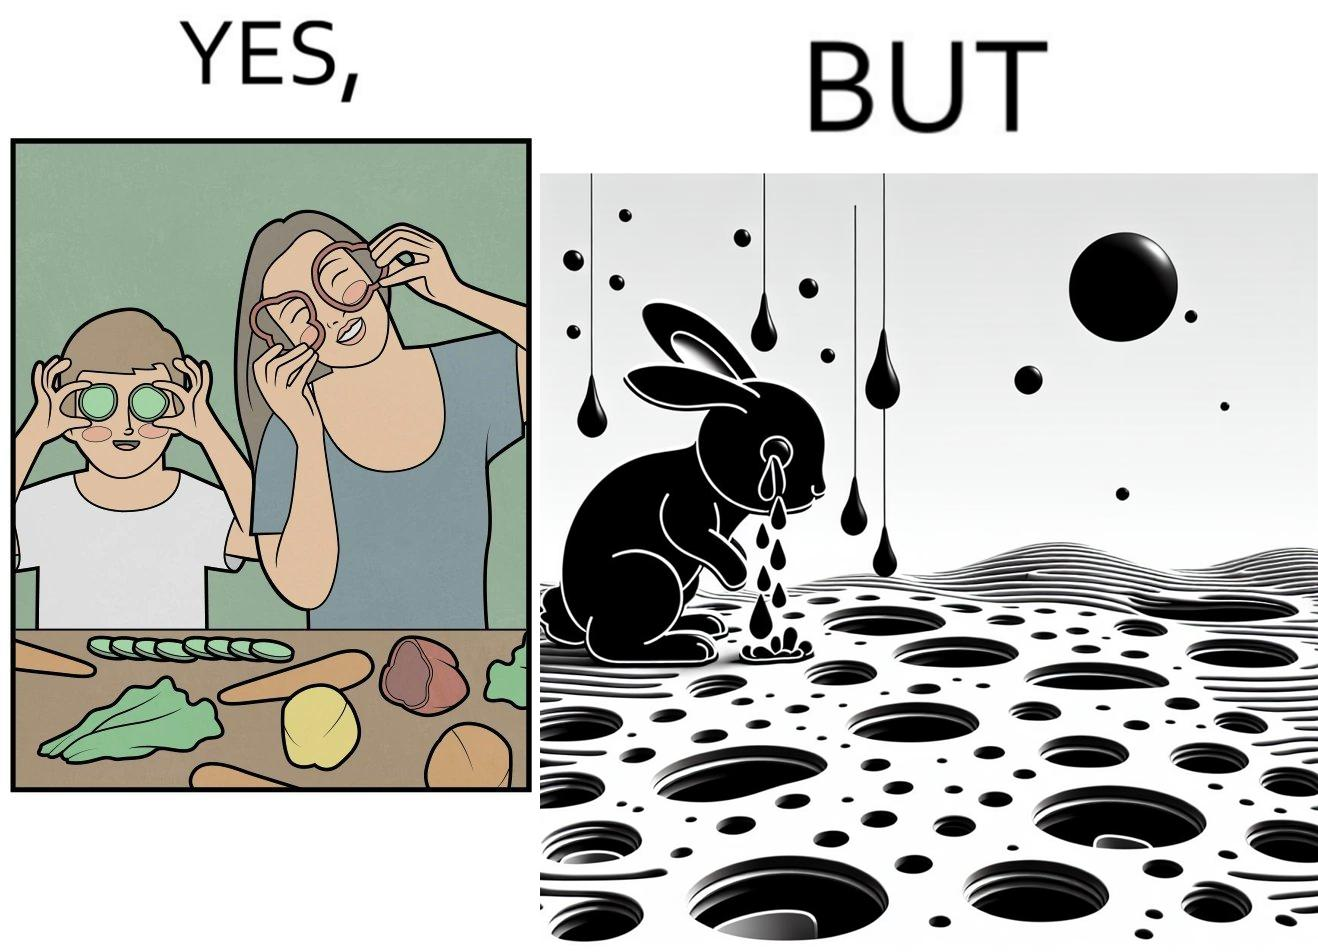Describe the contrast between the left and right parts of this image. In the left part of the image: It is a woman and child making funny shapes with vegetables and playing with them In the right part of the image: It is rabbit crying in a ground full of holes 